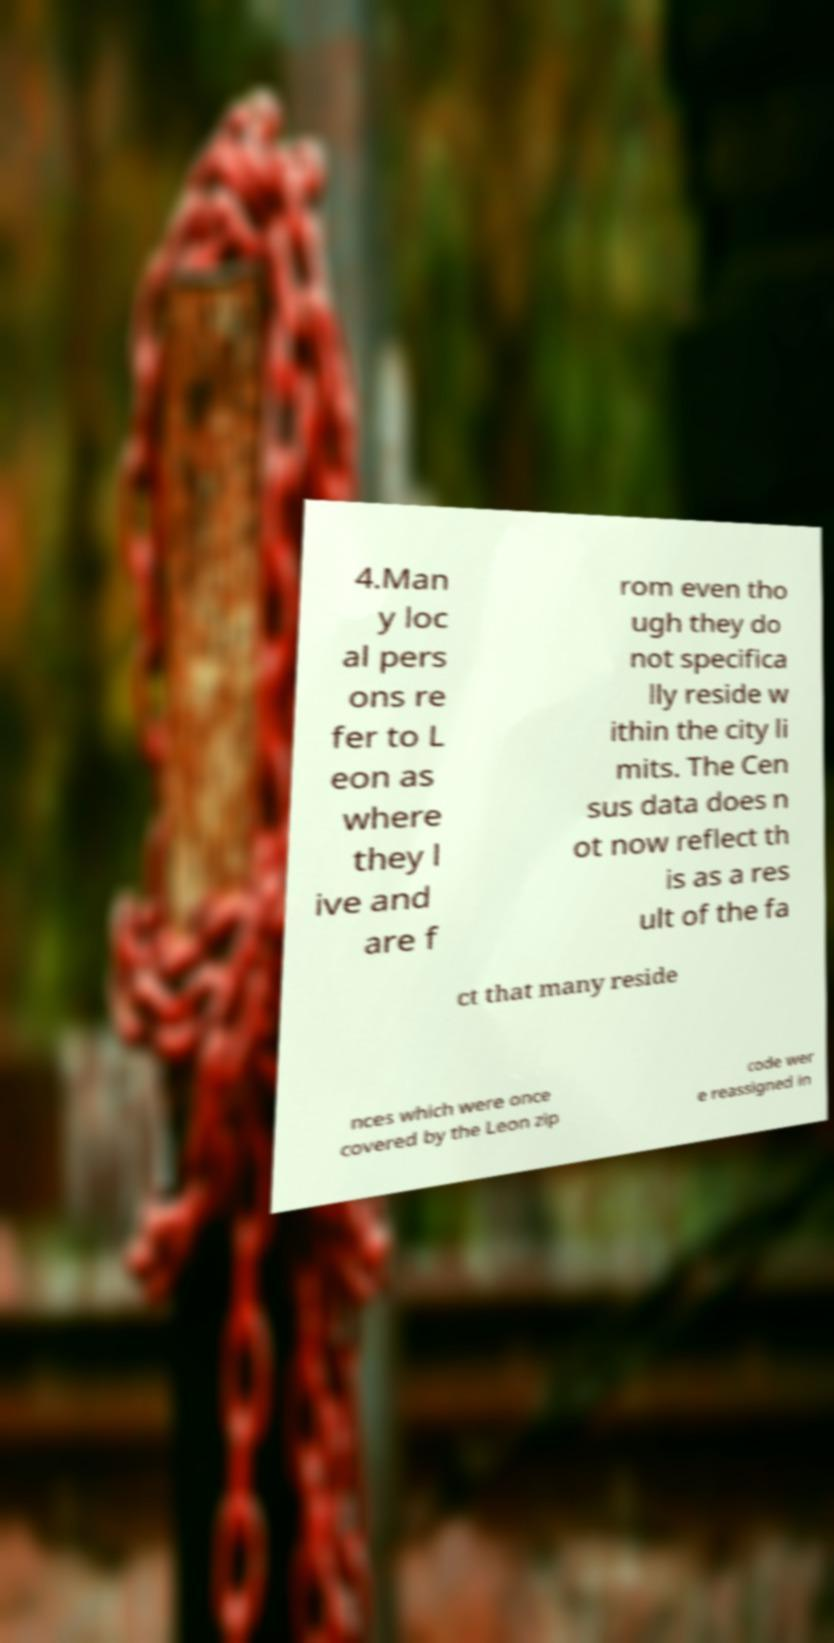What messages or text are displayed in this image? I need them in a readable, typed format. 4.Man y loc al pers ons re fer to L eon as where they l ive and are f rom even tho ugh they do not specifica lly reside w ithin the city li mits. The Cen sus data does n ot now reflect th is as a res ult of the fa ct that many reside nces which were once covered by the Leon zip code wer e reassigned in 